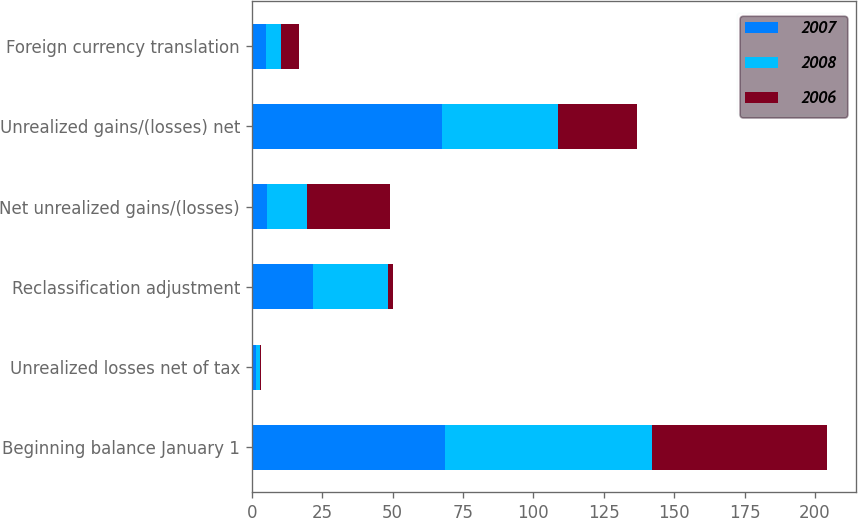Convert chart to OTSL. <chart><loc_0><loc_0><loc_500><loc_500><stacked_bar_chart><ecel><fcel>Beginning balance January 1<fcel>Unrealized losses net of tax<fcel>Reclassification adjustment<fcel>Net unrealized gains/(losses)<fcel>Unrealized gains/(losses) net<fcel>Foreign currency translation<nl><fcel>2007<fcel>68.8<fcel>1.5<fcel>21.6<fcel>5.3<fcel>67.6<fcel>5.2<nl><fcel>2008<fcel>73.5<fcel>1.4<fcel>26.9<fcel>14.4<fcel>41.3<fcel>5.3<nl><fcel>2006<fcel>62.1<fcel>0.5<fcel>1.5<fcel>29.3<fcel>27.8<fcel>6.4<nl></chart> 